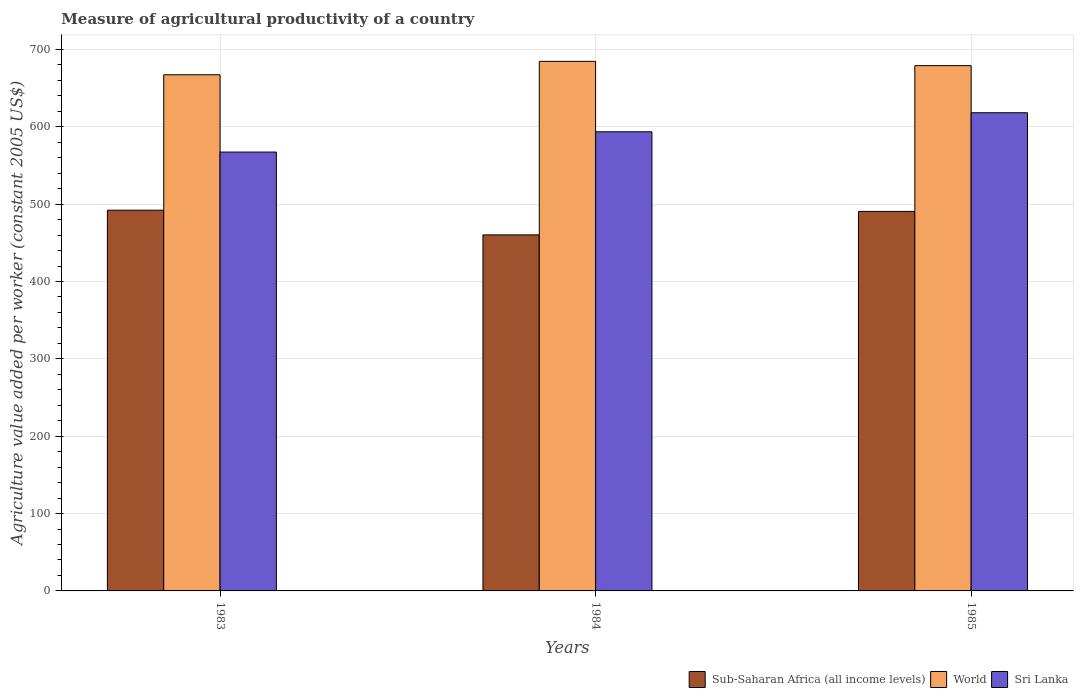How many bars are there on the 3rd tick from the right?
Make the answer very short. 3. What is the measure of agricultural productivity in Sri Lanka in 1985?
Offer a very short reply. 618.17. Across all years, what is the maximum measure of agricultural productivity in Sub-Saharan Africa (all income levels)?
Offer a very short reply. 492.2. Across all years, what is the minimum measure of agricultural productivity in Sub-Saharan Africa (all income levels)?
Offer a terse response. 460.29. In which year was the measure of agricultural productivity in World minimum?
Keep it short and to the point. 1983. What is the total measure of agricultural productivity in Sub-Saharan Africa (all income levels) in the graph?
Your answer should be very brief. 1443.12. What is the difference between the measure of agricultural productivity in Sub-Saharan Africa (all income levels) in 1984 and that in 1985?
Your response must be concise. -30.34. What is the difference between the measure of agricultural productivity in Sri Lanka in 1985 and the measure of agricultural productivity in World in 1984?
Offer a terse response. -66.44. What is the average measure of agricultural productivity in Sri Lanka per year?
Provide a short and direct response. 593.03. In the year 1985, what is the difference between the measure of agricultural productivity in Sri Lanka and measure of agricultural productivity in Sub-Saharan Africa (all income levels)?
Keep it short and to the point. 127.54. In how many years, is the measure of agricultural productivity in World greater than 520 US$?
Offer a very short reply. 3. What is the ratio of the measure of agricultural productivity in Sri Lanka in 1984 to that in 1985?
Make the answer very short. 0.96. Is the measure of agricultural productivity in World in 1984 less than that in 1985?
Provide a short and direct response. No. What is the difference between the highest and the second highest measure of agricultural productivity in World?
Provide a short and direct response. 5.5. What is the difference between the highest and the lowest measure of agricultural productivity in World?
Make the answer very short. 17.36. In how many years, is the measure of agricultural productivity in World greater than the average measure of agricultural productivity in World taken over all years?
Offer a very short reply. 2. What does the 1st bar from the right in 1985 represents?
Keep it short and to the point. Sri Lanka. Is it the case that in every year, the sum of the measure of agricultural productivity in Sub-Saharan Africa (all income levels) and measure of agricultural productivity in Sri Lanka is greater than the measure of agricultural productivity in World?
Keep it short and to the point. Yes. How many bars are there?
Your answer should be very brief. 9. How many years are there in the graph?
Make the answer very short. 3. Are the values on the major ticks of Y-axis written in scientific E-notation?
Ensure brevity in your answer.  No. Does the graph contain any zero values?
Offer a very short reply. No. How many legend labels are there?
Make the answer very short. 3. How are the legend labels stacked?
Your answer should be very brief. Horizontal. What is the title of the graph?
Provide a short and direct response. Measure of agricultural productivity of a country. What is the label or title of the X-axis?
Your answer should be compact. Years. What is the label or title of the Y-axis?
Offer a terse response. Agriculture value added per worker (constant 2005 US$). What is the Agriculture value added per worker (constant 2005 US$) of Sub-Saharan Africa (all income levels) in 1983?
Your answer should be very brief. 492.2. What is the Agriculture value added per worker (constant 2005 US$) in World in 1983?
Keep it short and to the point. 667.26. What is the Agriculture value added per worker (constant 2005 US$) of Sri Lanka in 1983?
Make the answer very short. 567.35. What is the Agriculture value added per worker (constant 2005 US$) of Sub-Saharan Africa (all income levels) in 1984?
Provide a short and direct response. 460.29. What is the Agriculture value added per worker (constant 2005 US$) of World in 1984?
Your answer should be compact. 684.61. What is the Agriculture value added per worker (constant 2005 US$) in Sri Lanka in 1984?
Keep it short and to the point. 593.56. What is the Agriculture value added per worker (constant 2005 US$) of Sub-Saharan Africa (all income levels) in 1985?
Ensure brevity in your answer.  490.63. What is the Agriculture value added per worker (constant 2005 US$) of World in 1985?
Make the answer very short. 679.11. What is the Agriculture value added per worker (constant 2005 US$) of Sri Lanka in 1985?
Your answer should be compact. 618.17. Across all years, what is the maximum Agriculture value added per worker (constant 2005 US$) of Sub-Saharan Africa (all income levels)?
Keep it short and to the point. 492.2. Across all years, what is the maximum Agriculture value added per worker (constant 2005 US$) of World?
Ensure brevity in your answer.  684.61. Across all years, what is the maximum Agriculture value added per worker (constant 2005 US$) in Sri Lanka?
Ensure brevity in your answer.  618.17. Across all years, what is the minimum Agriculture value added per worker (constant 2005 US$) in Sub-Saharan Africa (all income levels)?
Your answer should be very brief. 460.29. Across all years, what is the minimum Agriculture value added per worker (constant 2005 US$) in World?
Your response must be concise. 667.26. Across all years, what is the minimum Agriculture value added per worker (constant 2005 US$) in Sri Lanka?
Your answer should be compact. 567.35. What is the total Agriculture value added per worker (constant 2005 US$) of Sub-Saharan Africa (all income levels) in the graph?
Offer a terse response. 1443.12. What is the total Agriculture value added per worker (constant 2005 US$) of World in the graph?
Offer a very short reply. 2030.98. What is the total Agriculture value added per worker (constant 2005 US$) of Sri Lanka in the graph?
Offer a very short reply. 1779.08. What is the difference between the Agriculture value added per worker (constant 2005 US$) in Sub-Saharan Africa (all income levels) in 1983 and that in 1984?
Provide a short and direct response. 31.91. What is the difference between the Agriculture value added per worker (constant 2005 US$) in World in 1983 and that in 1984?
Offer a very short reply. -17.36. What is the difference between the Agriculture value added per worker (constant 2005 US$) in Sri Lanka in 1983 and that in 1984?
Offer a terse response. -26.21. What is the difference between the Agriculture value added per worker (constant 2005 US$) of Sub-Saharan Africa (all income levels) in 1983 and that in 1985?
Your answer should be very brief. 1.57. What is the difference between the Agriculture value added per worker (constant 2005 US$) of World in 1983 and that in 1985?
Provide a short and direct response. -11.85. What is the difference between the Agriculture value added per worker (constant 2005 US$) of Sri Lanka in 1983 and that in 1985?
Ensure brevity in your answer.  -50.82. What is the difference between the Agriculture value added per worker (constant 2005 US$) in Sub-Saharan Africa (all income levels) in 1984 and that in 1985?
Your answer should be very brief. -30.34. What is the difference between the Agriculture value added per worker (constant 2005 US$) of World in 1984 and that in 1985?
Keep it short and to the point. 5.5. What is the difference between the Agriculture value added per worker (constant 2005 US$) in Sri Lanka in 1984 and that in 1985?
Offer a terse response. -24.61. What is the difference between the Agriculture value added per worker (constant 2005 US$) of Sub-Saharan Africa (all income levels) in 1983 and the Agriculture value added per worker (constant 2005 US$) of World in 1984?
Give a very brief answer. -192.42. What is the difference between the Agriculture value added per worker (constant 2005 US$) of Sub-Saharan Africa (all income levels) in 1983 and the Agriculture value added per worker (constant 2005 US$) of Sri Lanka in 1984?
Ensure brevity in your answer.  -101.36. What is the difference between the Agriculture value added per worker (constant 2005 US$) of World in 1983 and the Agriculture value added per worker (constant 2005 US$) of Sri Lanka in 1984?
Make the answer very short. 73.7. What is the difference between the Agriculture value added per worker (constant 2005 US$) of Sub-Saharan Africa (all income levels) in 1983 and the Agriculture value added per worker (constant 2005 US$) of World in 1985?
Give a very brief answer. -186.91. What is the difference between the Agriculture value added per worker (constant 2005 US$) of Sub-Saharan Africa (all income levels) in 1983 and the Agriculture value added per worker (constant 2005 US$) of Sri Lanka in 1985?
Offer a very short reply. -125.97. What is the difference between the Agriculture value added per worker (constant 2005 US$) of World in 1983 and the Agriculture value added per worker (constant 2005 US$) of Sri Lanka in 1985?
Your answer should be very brief. 49.09. What is the difference between the Agriculture value added per worker (constant 2005 US$) of Sub-Saharan Africa (all income levels) in 1984 and the Agriculture value added per worker (constant 2005 US$) of World in 1985?
Your response must be concise. -218.82. What is the difference between the Agriculture value added per worker (constant 2005 US$) in Sub-Saharan Africa (all income levels) in 1984 and the Agriculture value added per worker (constant 2005 US$) in Sri Lanka in 1985?
Offer a terse response. -157.89. What is the difference between the Agriculture value added per worker (constant 2005 US$) in World in 1984 and the Agriculture value added per worker (constant 2005 US$) in Sri Lanka in 1985?
Ensure brevity in your answer.  66.44. What is the average Agriculture value added per worker (constant 2005 US$) in Sub-Saharan Africa (all income levels) per year?
Ensure brevity in your answer.  481.04. What is the average Agriculture value added per worker (constant 2005 US$) of World per year?
Offer a very short reply. 676.99. What is the average Agriculture value added per worker (constant 2005 US$) in Sri Lanka per year?
Offer a very short reply. 593.03. In the year 1983, what is the difference between the Agriculture value added per worker (constant 2005 US$) of Sub-Saharan Africa (all income levels) and Agriculture value added per worker (constant 2005 US$) of World?
Ensure brevity in your answer.  -175.06. In the year 1983, what is the difference between the Agriculture value added per worker (constant 2005 US$) in Sub-Saharan Africa (all income levels) and Agriculture value added per worker (constant 2005 US$) in Sri Lanka?
Your response must be concise. -75.15. In the year 1983, what is the difference between the Agriculture value added per worker (constant 2005 US$) in World and Agriculture value added per worker (constant 2005 US$) in Sri Lanka?
Provide a short and direct response. 99.91. In the year 1984, what is the difference between the Agriculture value added per worker (constant 2005 US$) of Sub-Saharan Africa (all income levels) and Agriculture value added per worker (constant 2005 US$) of World?
Ensure brevity in your answer.  -224.33. In the year 1984, what is the difference between the Agriculture value added per worker (constant 2005 US$) of Sub-Saharan Africa (all income levels) and Agriculture value added per worker (constant 2005 US$) of Sri Lanka?
Ensure brevity in your answer.  -133.27. In the year 1984, what is the difference between the Agriculture value added per worker (constant 2005 US$) of World and Agriculture value added per worker (constant 2005 US$) of Sri Lanka?
Your answer should be compact. 91.05. In the year 1985, what is the difference between the Agriculture value added per worker (constant 2005 US$) of Sub-Saharan Africa (all income levels) and Agriculture value added per worker (constant 2005 US$) of World?
Offer a terse response. -188.48. In the year 1985, what is the difference between the Agriculture value added per worker (constant 2005 US$) of Sub-Saharan Africa (all income levels) and Agriculture value added per worker (constant 2005 US$) of Sri Lanka?
Offer a terse response. -127.54. In the year 1985, what is the difference between the Agriculture value added per worker (constant 2005 US$) of World and Agriculture value added per worker (constant 2005 US$) of Sri Lanka?
Give a very brief answer. 60.94. What is the ratio of the Agriculture value added per worker (constant 2005 US$) in Sub-Saharan Africa (all income levels) in 1983 to that in 1984?
Ensure brevity in your answer.  1.07. What is the ratio of the Agriculture value added per worker (constant 2005 US$) of World in 1983 to that in 1984?
Your answer should be compact. 0.97. What is the ratio of the Agriculture value added per worker (constant 2005 US$) of Sri Lanka in 1983 to that in 1984?
Keep it short and to the point. 0.96. What is the ratio of the Agriculture value added per worker (constant 2005 US$) in Sub-Saharan Africa (all income levels) in 1983 to that in 1985?
Provide a succinct answer. 1. What is the ratio of the Agriculture value added per worker (constant 2005 US$) of World in 1983 to that in 1985?
Offer a terse response. 0.98. What is the ratio of the Agriculture value added per worker (constant 2005 US$) in Sri Lanka in 1983 to that in 1985?
Make the answer very short. 0.92. What is the ratio of the Agriculture value added per worker (constant 2005 US$) in Sub-Saharan Africa (all income levels) in 1984 to that in 1985?
Provide a short and direct response. 0.94. What is the ratio of the Agriculture value added per worker (constant 2005 US$) of World in 1984 to that in 1985?
Give a very brief answer. 1.01. What is the ratio of the Agriculture value added per worker (constant 2005 US$) in Sri Lanka in 1984 to that in 1985?
Offer a very short reply. 0.96. What is the difference between the highest and the second highest Agriculture value added per worker (constant 2005 US$) of Sub-Saharan Africa (all income levels)?
Make the answer very short. 1.57. What is the difference between the highest and the second highest Agriculture value added per worker (constant 2005 US$) in World?
Make the answer very short. 5.5. What is the difference between the highest and the second highest Agriculture value added per worker (constant 2005 US$) of Sri Lanka?
Offer a terse response. 24.61. What is the difference between the highest and the lowest Agriculture value added per worker (constant 2005 US$) of Sub-Saharan Africa (all income levels)?
Provide a short and direct response. 31.91. What is the difference between the highest and the lowest Agriculture value added per worker (constant 2005 US$) in World?
Offer a very short reply. 17.36. What is the difference between the highest and the lowest Agriculture value added per worker (constant 2005 US$) of Sri Lanka?
Make the answer very short. 50.82. 